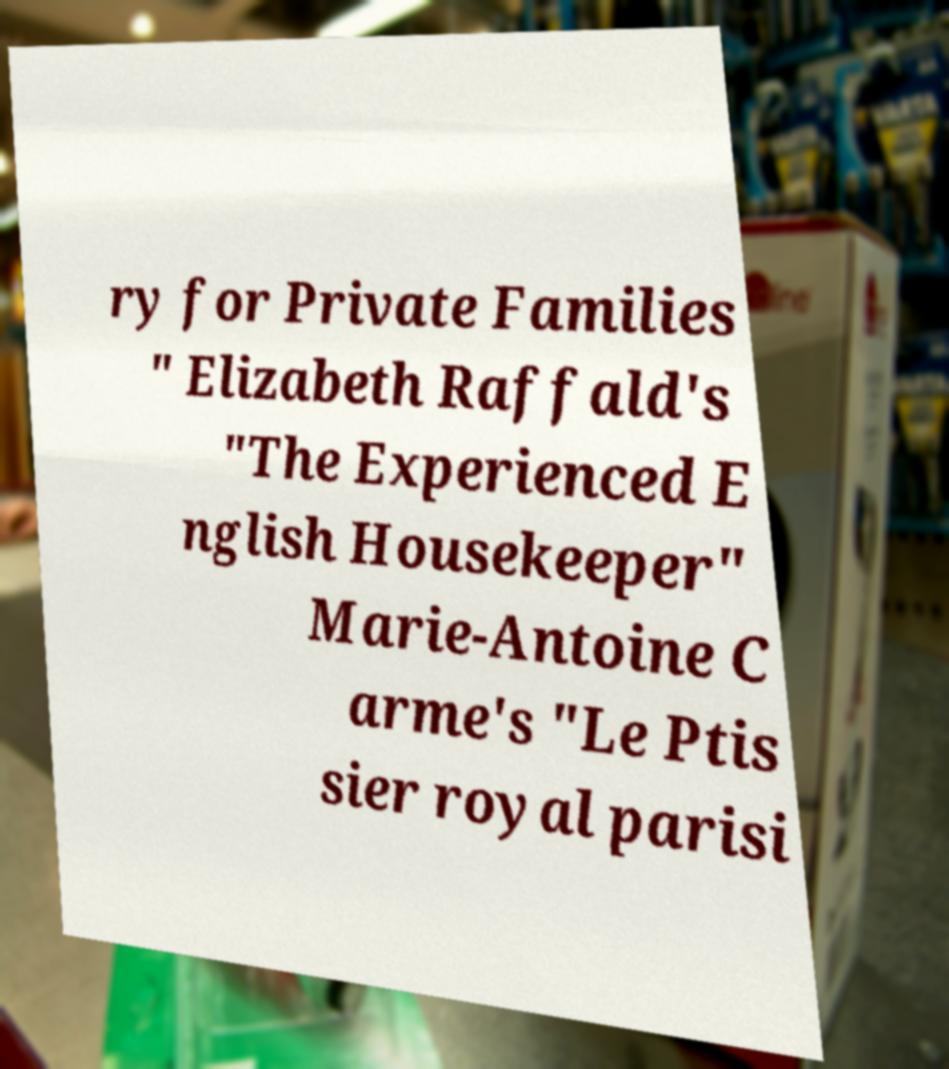What messages or text are displayed in this image? I need them in a readable, typed format. ry for Private Families " Elizabeth Raffald's "The Experienced E nglish Housekeeper" Marie-Antoine C arme's "Le Ptis sier royal parisi 